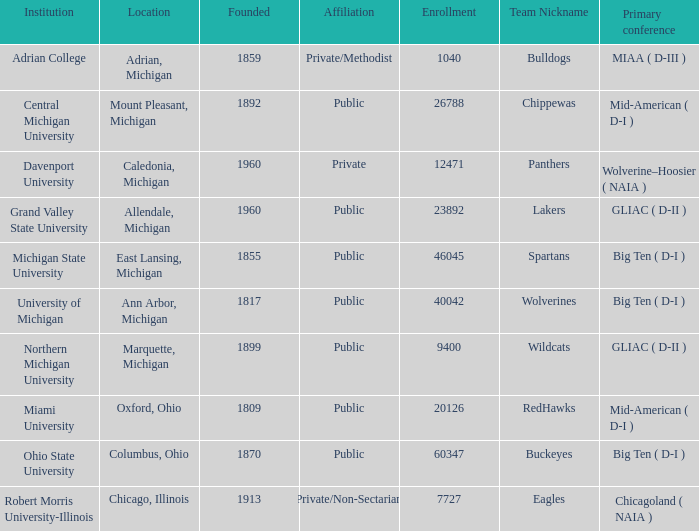In allendale, michigan, how many primary conferences took place? 1.0. 